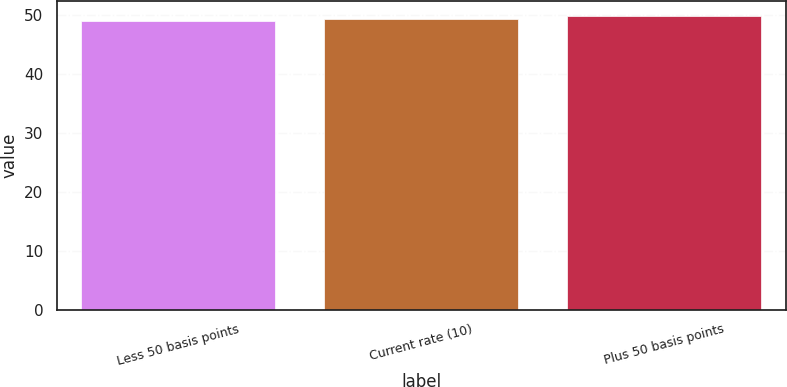Convert chart. <chart><loc_0><loc_0><loc_500><loc_500><bar_chart><fcel>Less 50 basis points<fcel>Current rate (10)<fcel>Plus 50 basis points<nl><fcel>48.9<fcel>49.3<fcel>49.8<nl></chart> 